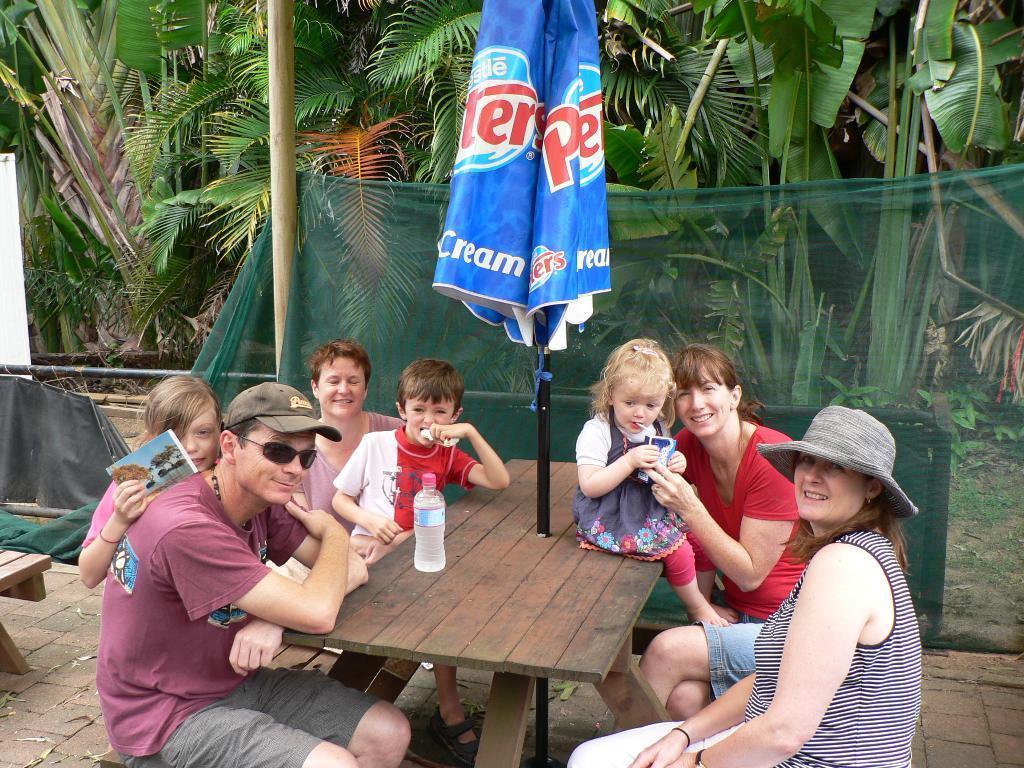Could you give a brief overview of what you see in this image? people are sitting on the bench across the wooden table. on the table there is a water bottle and a closed umbrella. behind them there are trees. 